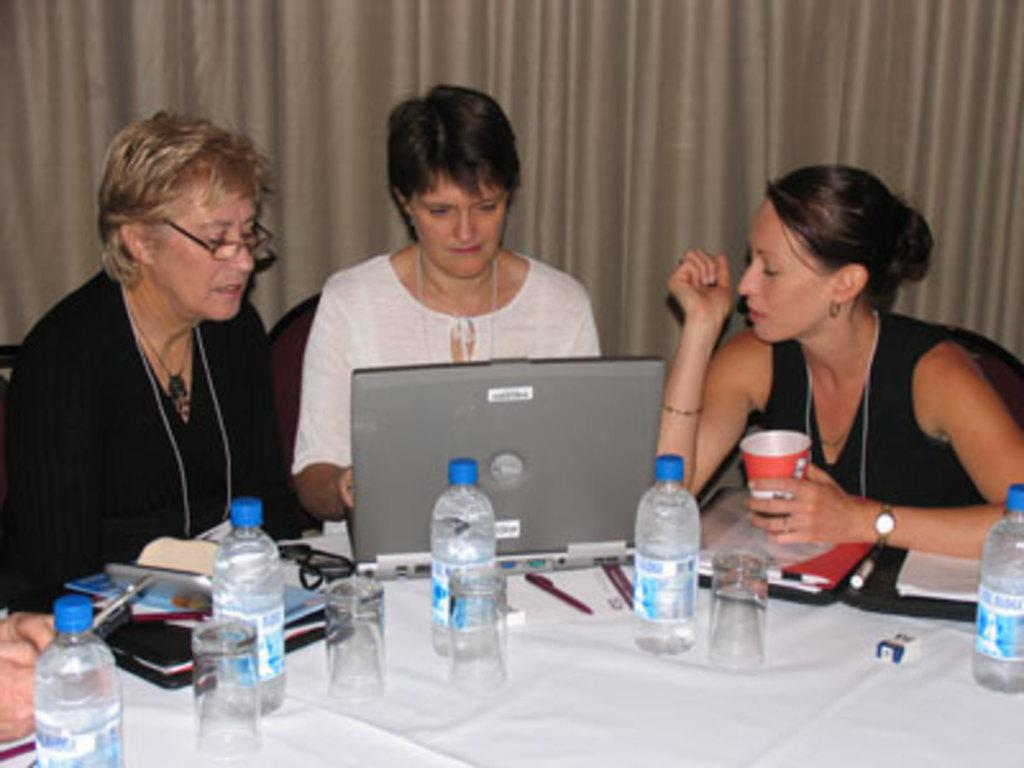How many people are in the image? There are three persons in the image. What are the persons doing in the image? The persons are sitting on chairs. What is on the table in the image? There are glasses, bottles, and a laptop on the table. What is visible in the background of the image? There is a curtain in the background of the image. Can you see any badges on the persons in the image? There is no mention of badges in the image, so we cannot determine if any are present. What type of grass can be seen in the image? There is no grass visible in the image; it features a table with chairs and people sitting on them. 